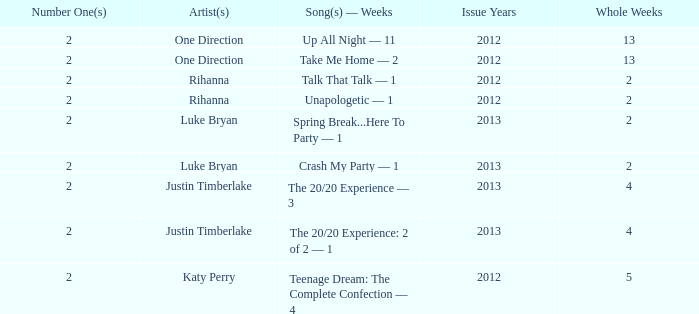For rihanna's songs in 2012, which titles reached the top spot and what was the duration of their stay at #1? Talk That Talk — 1, Unapologetic — 1. 